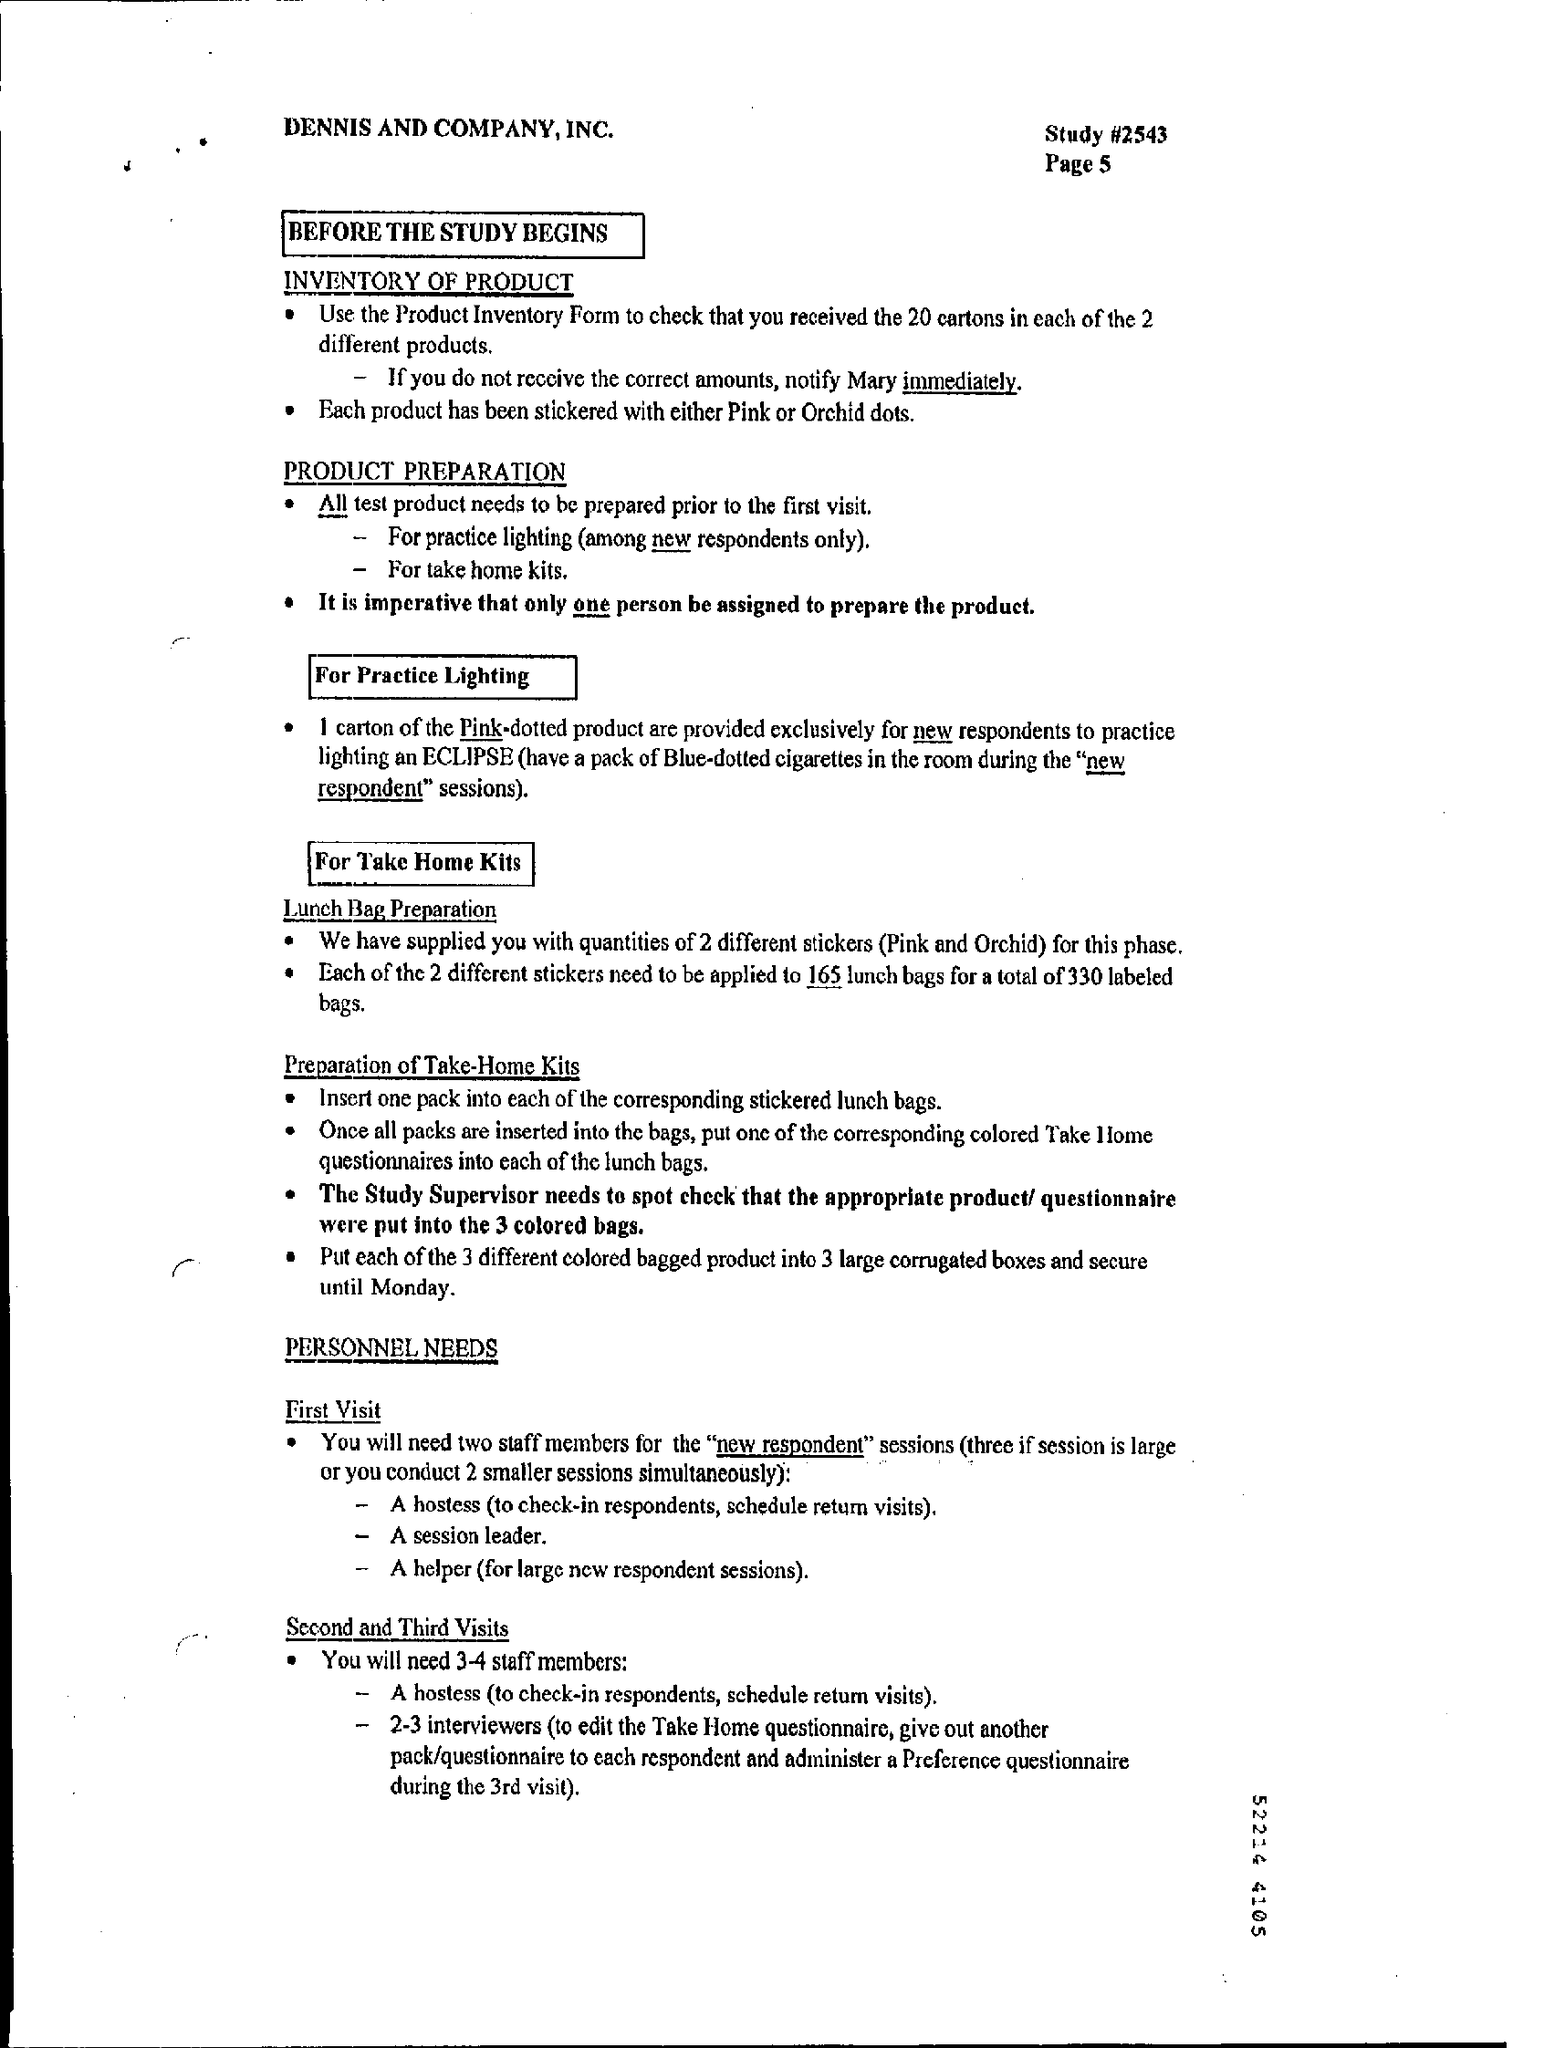What is the Study #?
Provide a short and direct response. #2543. How many persons should be assigned to prepare the product?
Your answer should be compact. One. Who needs to spot check that the appropriate product/questionnaire were put int the 3 coloured bags?
Make the answer very short. Study supervisor. 